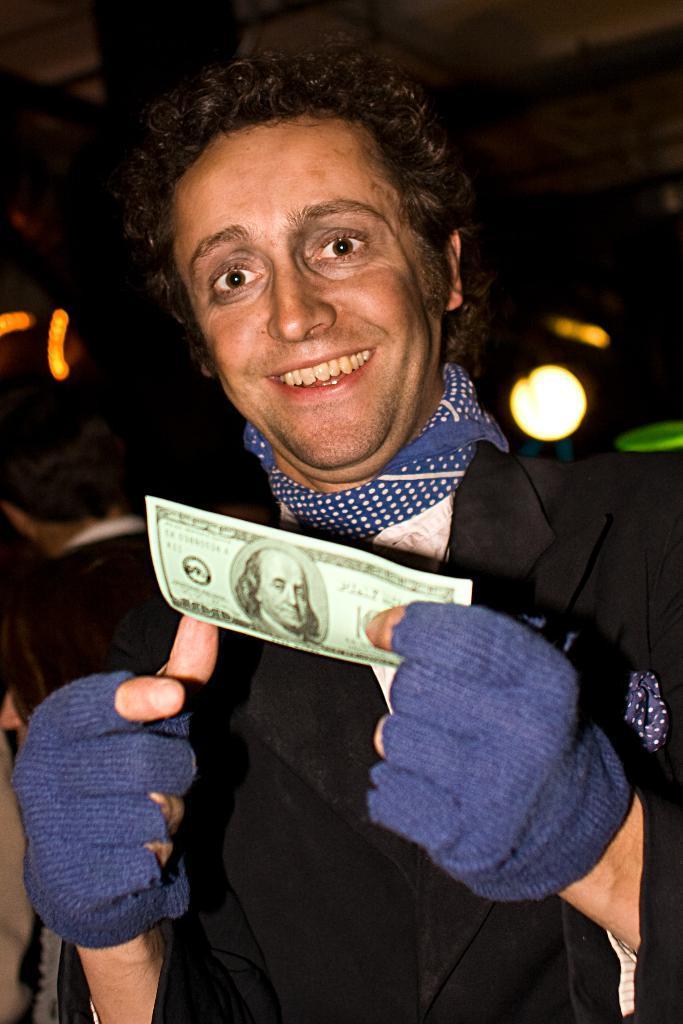Please provide a concise description of this image. In this image in the front there is a person standing and smiling and holding a paper in his hand. And the background is blurry and there is light visible in the background. 